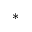<formula> <loc_0><loc_0><loc_500><loc_500>^ { \ast }</formula> 